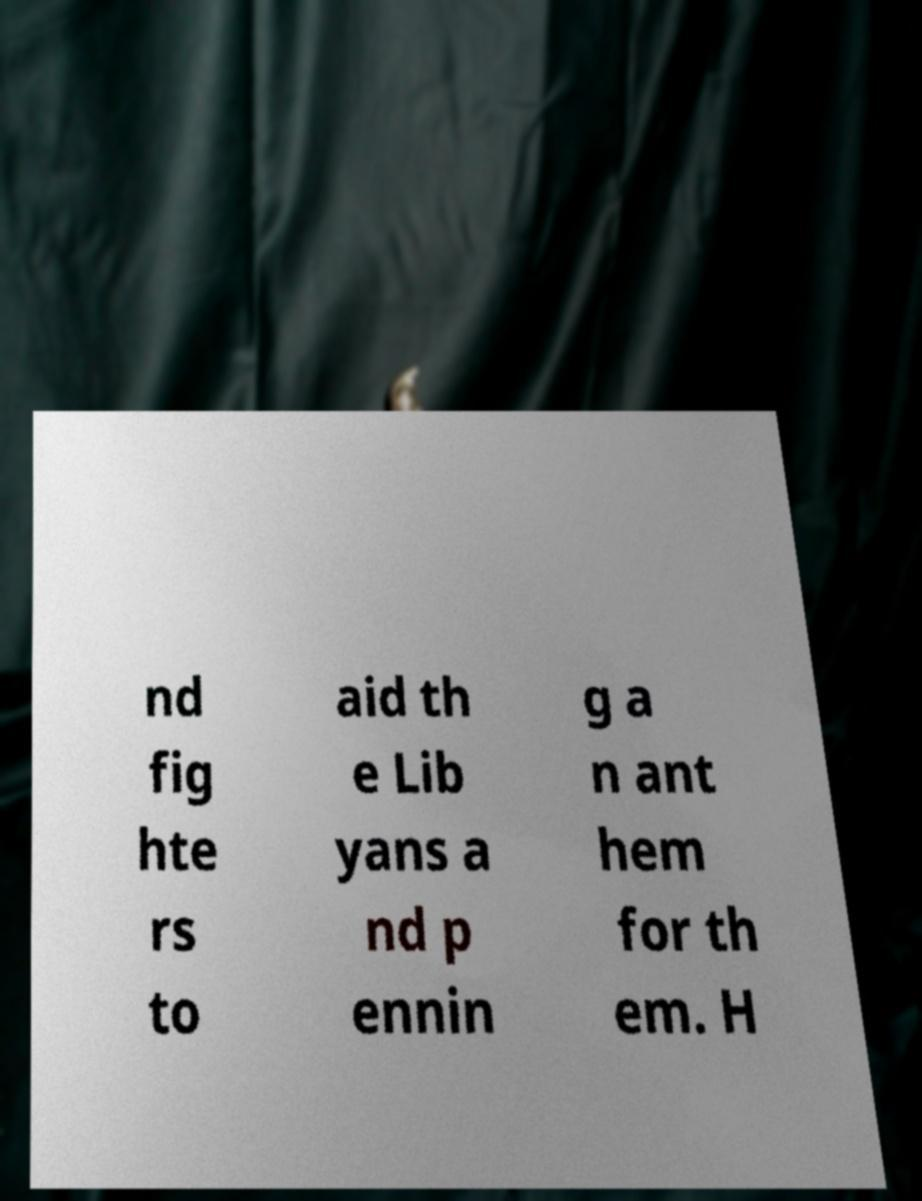Can you accurately transcribe the text from the provided image for me? nd fig hte rs to aid th e Lib yans a nd p ennin g a n ant hem for th em. H 